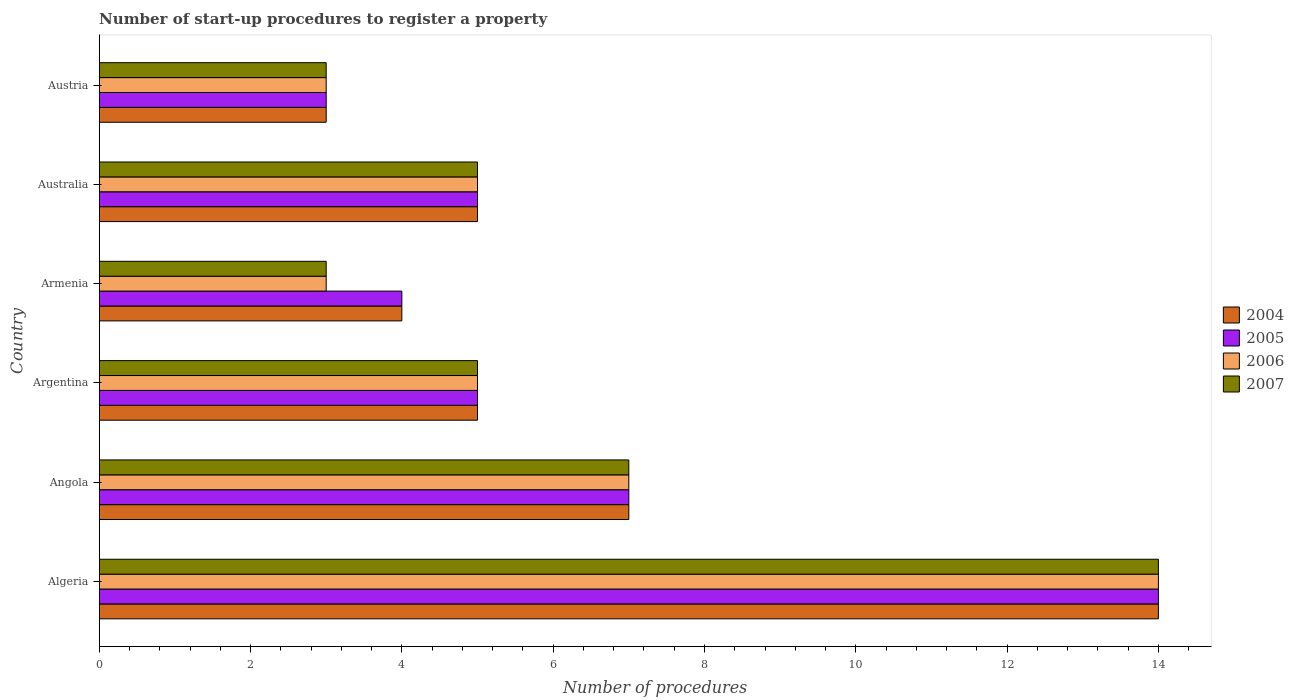How many groups of bars are there?
Offer a terse response. 6. Are the number of bars per tick equal to the number of legend labels?
Your response must be concise. Yes. Across all countries, what is the maximum number of procedures required to register a property in 2006?
Provide a short and direct response. 14. Across all countries, what is the minimum number of procedures required to register a property in 2006?
Ensure brevity in your answer.  3. In which country was the number of procedures required to register a property in 2006 maximum?
Give a very brief answer. Algeria. In which country was the number of procedures required to register a property in 2006 minimum?
Give a very brief answer. Armenia. What is the difference between the number of procedures required to register a property in 2005 in Algeria and that in Armenia?
Provide a short and direct response. 10. What is the average number of procedures required to register a property in 2005 per country?
Ensure brevity in your answer.  6.33. What is the difference between the number of procedures required to register a property in 2005 and number of procedures required to register a property in 2006 in Australia?
Give a very brief answer. 0. In how many countries, is the number of procedures required to register a property in 2005 greater than 8.8 ?
Provide a short and direct response. 1. What is the ratio of the number of procedures required to register a property in 2006 in Australia to that in Austria?
Make the answer very short. 1.67. Is the difference between the number of procedures required to register a property in 2005 in Armenia and Australia greater than the difference between the number of procedures required to register a property in 2006 in Armenia and Australia?
Your answer should be compact. Yes. What is the difference between the highest and the second highest number of procedures required to register a property in 2007?
Provide a short and direct response. 7. What is the difference between the highest and the lowest number of procedures required to register a property in 2004?
Offer a very short reply. 11. Is it the case that in every country, the sum of the number of procedures required to register a property in 2004 and number of procedures required to register a property in 2007 is greater than the number of procedures required to register a property in 2005?
Offer a terse response. Yes. How many bars are there?
Offer a terse response. 24. Are all the bars in the graph horizontal?
Give a very brief answer. Yes. How many countries are there in the graph?
Keep it short and to the point. 6. Are the values on the major ticks of X-axis written in scientific E-notation?
Your response must be concise. No. Does the graph contain grids?
Offer a terse response. No. Where does the legend appear in the graph?
Your answer should be compact. Center right. How many legend labels are there?
Your response must be concise. 4. How are the legend labels stacked?
Give a very brief answer. Vertical. What is the title of the graph?
Keep it short and to the point. Number of start-up procedures to register a property. What is the label or title of the X-axis?
Provide a short and direct response. Number of procedures. What is the label or title of the Y-axis?
Keep it short and to the point. Country. What is the Number of procedures of 2004 in Algeria?
Keep it short and to the point. 14. What is the Number of procedures of 2006 in Algeria?
Your response must be concise. 14. What is the Number of procedures of 2004 in Angola?
Keep it short and to the point. 7. What is the Number of procedures of 2007 in Angola?
Ensure brevity in your answer.  7. What is the Number of procedures in 2007 in Argentina?
Keep it short and to the point. 5. What is the Number of procedures of 2005 in Armenia?
Your answer should be very brief. 4. What is the Number of procedures of 2005 in Australia?
Your response must be concise. 5. What is the Number of procedures of 2006 in Australia?
Your answer should be very brief. 5. What is the Number of procedures in 2004 in Austria?
Give a very brief answer. 3. What is the Number of procedures in 2007 in Austria?
Provide a short and direct response. 3. Across all countries, what is the maximum Number of procedures of 2004?
Ensure brevity in your answer.  14. Across all countries, what is the maximum Number of procedures of 2006?
Your answer should be compact. 14. Across all countries, what is the maximum Number of procedures of 2007?
Your answer should be compact. 14. Across all countries, what is the minimum Number of procedures in 2004?
Offer a very short reply. 3. Across all countries, what is the minimum Number of procedures in 2005?
Provide a short and direct response. 3. Across all countries, what is the minimum Number of procedures in 2006?
Provide a short and direct response. 3. What is the total Number of procedures of 2004 in the graph?
Give a very brief answer. 38. What is the difference between the Number of procedures of 2006 in Algeria and that in Angola?
Give a very brief answer. 7. What is the difference between the Number of procedures in 2005 in Algeria and that in Argentina?
Provide a succinct answer. 9. What is the difference between the Number of procedures of 2006 in Algeria and that in Argentina?
Provide a short and direct response. 9. What is the difference between the Number of procedures in 2007 in Algeria and that in Argentina?
Keep it short and to the point. 9. What is the difference between the Number of procedures of 2004 in Algeria and that in Armenia?
Your answer should be very brief. 10. What is the difference between the Number of procedures in 2006 in Algeria and that in Armenia?
Give a very brief answer. 11. What is the difference between the Number of procedures in 2004 in Algeria and that in Australia?
Your response must be concise. 9. What is the difference between the Number of procedures of 2007 in Algeria and that in Australia?
Your answer should be very brief. 9. What is the difference between the Number of procedures in 2004 in Angola and that in Argentina?
Ensure brevity in your answer.  2. What is the difference between the Number of procedures in 2007 in Angola and that in Argentina?
Ensure brevity in your answer.  2. What is the difference between the Number of procedures of 2006 in Angola and that in Armenia?
Offer a very short reply. 4. What is the difference between the Number of procedures in 2007 in Angola and that in Armenia?
Provide a short and direct response. 4. What is the difference between the Number of procedures in 2006 in Angola and that in Australia?
Your response must be concise. 2. What is the difference between the Number of procedures in 2007 in Angola and that in Australia?
Offer a very short reply. 2. What is the difference between the Number of procedures of 2004 in Angola and that in Austria?
Your answer should be very brief. 4. What is the difference between the Number of procedures in 2005 in Angola and that in Austria?
Ensure brevity in your answer.  4. What is the difference between the Number of procedures in 2004 in Argentina and that in Armenia?
Offer a terse response. 1. What is the difference between the Number of procedures of 2005 in Argentina and that in Armenia?
Provide a short and direct response. 1. What is the difference between the Number of procedures of 2004 in Argentina and that in Australia?
Make the answer very short. 0. What is the difference between the Number of procedures of 2005 in Argentina and that in Australia?
Keep it short and to the point. 0. What is the difference between the Number of procedures in 2007 in Argentina and that in Australia?
Your answer should be compact. 0. What is the difference between the Number of procedures of 2006 in Argentina and that in Austria?
Your answer should be very brief. 2. What is the difference between the Number of procedures in 2007 in Argentina and that in Austria?
Your answer should be very brief. 2. What is the difference between the Number of procedures in 2005 in Armenia and that in Australia?
Offer a very short reply. -1. What is the difference between the Number of procedures of 2007 in Armenia and that in Australia?
Keep it short and to the point. -2. What is the difference between the Number of procedures in 2006 in Armenia and that in Austria?
Your answer should be compact. 0. What is the difference between the Number of procedures in 2007 in Armenia and that in Austria?
Give a very brief answer. 0. What is the difference between the Number of procedures of 2005 in Australia and that in Austria?
Your response must be concise. 2. What is the difference between the Number of procedures of 2006 in Australia and that in Austria?
Your response must be concise. 2. What is the difference between the Number of procedures of 2007 in Australia and that in Austria?
Keep it short and to the point. 2. What is the difference between the Number of procedures in 2004 in Algeria and the Number of procedures in 2005 in Angola?
Ensure brevity in your answer.  7. What is the difference between the Number of procedures in 2004 in Algeria and the Number of procedures in 2006 in Angola?
Offer a terse response. 7. What is the difference between the Number of procedures in 2005 in Algeria and the Number of procedures in 2006 in Angola?
Provide a short and direct response. 7. What is the difference between the Number of procedures in 2004 in Algeria and the Number of procedures in 2007 in Argentina?
Your response must be concise. 9. What is the difference between the Number of procedures of 2005 in Algeria and the Number of procedures of 2006 in Argentina?
Make the answer very short. 9. What is the difference between the Number of procedures in 2006 in Algeria and the Number of procedures in 2007 in Argentina?
Offer a terse response. 9. What is the difference between the Number of procedures of 2004 in Algeria and the Number of procedures of 2005 in Armenia?
Provide a short and direct response. 10. What is the difference between the Number of procedures in 2004 in Algeria and the Number of procedures in 2007 in Armenia?
Offer a very short reply. 11. What is the difference between the Number of procedures in 2005 in Algeria and the Number of procedures in 2007 in Armenia?
Keep it short and to the point. 11. What is the difference between the Number of procedures in 2004 in Algeria and the Number of procedures in 2005 in Australia?
Your answer should be compact. 9. What is the difference between the Number of procedures in 2004 in Algeria and the Number of procedures in 2007 in Australia?
Your response must be concise. 9. What is the difference between the Number of procedures in 2005 in Algeria and the Number of procedures in 2007 in Australia?
Offer a very short reply. 9. What is the difference between the Number of procedures of 2004 in Algeria and the Number of procedures of 2006 in Austria?
Your answer should be very brief. 11. What is the difference between the Number of procedures in 2005 in Algeria and the Number of procedures in 2006 in Austria?
Make the answer very short. 11. What is the difference between the Number of procedures of 2005 in Algeria and the Number of procedures of 2007 in Austria?
Offer a terse response. 11. What is the difference between the Number of procedures in 2004 in Angola and the Number of procedures in 2005 in Argentina?
Provide a short and direct response. 2. What is the difference between the Number of procedures of 2004 in Angola and the Number of procedures of 2006 in Argentina?
Provide a succinct answer. 2. What is the difference between the Number of procedures of 2004 in Angola and the Number of procedures of 2007 in Argentina?
Offer a terse response. 2. What is the difference between the Number of procedures of 2005 in Angola and the Number of procedures of 2006 in Argentina?
Keep it short and to the point. 2. What is the difference between the Number of procedures in 2006 in Angola and the Number of procedures in 2007 in Argentina?
Provide a succinct answer. 2. What is the difference between the Number of procedures in 2004 in Angola and the Number of procedures in 2007 in Armenia?
Make the answer very short. 4. What is the difference between the Number of procedures of 2005 in Angola and the Number of procedures of 2007 in Armenia?
Offer a terse response. 4. What is the difference between the Number of procedures of 2006 in Angola and the Number of procedures of 2007 in Armenia?
Your answer should be compact. 4. What is the difference between the Number of procedures of 2004 in Angola and the Number of procedures of 2006 in Australia?
Make the answer very short. 2. What is the difference between the Number of procedures of 2005 in Angola and the Number of procedures of 2007 in Australia?
Make the answer very short. 2. What is the difference between the Number of procedures of 2004 in Angola and the Number of procedures of 2005 in Austria?
Your answer should be very brief. 4. What is the difference between the Number of procedures in 2005 in Angola and the Number of procedures in 2007 in Austria?
Give a very brief answer. 4. What is the difference between the Number of procedures in 2006 in Angola and the Number of procedures in 2007 in Austria?
Offer a very short reply. 4. What is the difference between the Number of procedures of 2004 in Argentina and the Number of procedures of 2005 in Armenia?
Make the answer very short. 1. What is the difference between the Number of procedures in 2004 in Argentina and the Number of procedures in 2007 in Armenia?
Provide a short and direct response. 2. What is the difference between the Number of procedures of 2005 in Argentina and the Number of procedures of 2006 in Armenia?
Your answer should be very brief. 2. What is the difference between the Number of procedures of 2006 in Argentina and the Number of procedures of 2007 in Armenia?
Your answer should be compact. 2. What is the difference between the Number of procedures in 2004 in Argentina and the Number of procedures in 2005 in Australia?
Offer a terse response. 0. What is the difference between the Number of procedures in 2004 in Argentina and the Number of procedures in 2006 in Australia?
Your response must be concise. 0. What is the difference between the Number of procedures of 2004 in Argentina and the Number of procedures of 2007 in Australia?
Give a very brief answer. 0. What is the difference between the Number of procedures in 2005 in Argentina and the Number of procedures in 2007 in Australia?
Your answer should be very brief. 0. What is the difference between the Number of procedures in 2004 in Argentina and the Number of procedures in 2007 in Austria?
Your answer should be very brief. 2. What is the difference between the Number of procedures of 2005 in Argentina and the Number of procedures of 2006 in Austria?
Ensure brevity in your answer.  2. What is the difference between the Number of procedures of 2005 in Argentina and the Number of procedures of 2007 in Austria?
Provide a succinct answer. 2. What is the difference between the Number of procedures of 2004 in Armenia and the Number of procedures of 2005 in Australia?
Your response must be concise. -1. What is the difference between the Number of procedures in 2004 in Armenia and the Number of procedures in 2006 in Australia?
Your answer should be very brief. -1. What is the difference between the Number of procedures of 2005 in Armenia and the Number of procedures of 2006 in Australia?
Ensure brevity in your answer.  -1. What is the difference between the Number of procedures of 2005 in Armenia and the Number of procedures of 2007 in Australia?
Your answer should be compact. -1. What is the difference between the Number of procedures of 2004 in Armenia and the Number of procedures of 2005 in Austria?
Your response must be concise. 1. What is the difference between the Number of procedures in 2005 in Armenia and the Number of procedures in 2006 in Austria?
Keep it short and to the point. 1. What is the difference between the Number of procedures of 2005 in Armenia and the Number of procedures of 2007 in Austria?
Give a very brief answer. 1. What is the difference between the Number of procedures in 2006 in Armenia and the Number of procedures in 2007 in Austria?
Ensure brevity in your answer.  0. What is the difference between the Number of procedures in 2004 in Australia and the Number of procedures in 2005 in Austria?
Provide a succinct answer. 2. What is the difference between the Number of procedures of 2005 in Australia and the Number of procedures of 2006 in Austria?
Provide a succinct answer. 2. What is the average Number of procedures of 2004 per country?
Provide a short and direct response. 6.33. What is the average Number of procedures in 2005 per country?
Offer a very short reply. 6.33. What is the average Number of procedures of 2006 per country?
Make the answer very short. 6.17. What is the average Number of procedures in 2007 per country?
Your answer should be compact. 6.17. What is the difference between the Number of procedures in 2004 and Number of procedures in 2006 in Algeria?
Ensure brevity in your answer.  0. What is the difference between the Number of procedures in 2006 and Number of procedures in 2007 in Algeria?
Offer a terse response. 0. What is the difference between the Number of procedures in 2004 and Number of procedures in 2007 in Angola?
Your response must be concise. 0. What is the difference between the Number of procedures in 2005 and Number of procedures in 2007 in Angola?
Provide a succinct answer. 0. What is the difference between the Number of procedures of 2006 and Number of procedures of 2007 in Angola?
Make the answer very short. 0. What is the difference between the Number of procedures in 2004 and Number of procedures in 2006 in Argentina?
Provide a succinct answer. 0. What is the difference between the Number of procedures of 2004 and Number of procedures of 2007 in Argentina?
Your answer should be compact. 0. What is the difference between the Number of procedures in 2005 and Number of procedures in 2006 in Argentina?
Provide a succinct answer. 0. What is the difference between the Number of procedures of 2006 and Number of procedures of 2007 in Argentina?
Make the answer very short. 0. What is the difference between the Number of procedures in 2004 and Number of procedures in 2005 in Armenia?
Your answer should be very brief. 0. What is the difference between the Number of procedures of 2006 and Number of procedures of 2007 in Armenia?
Ensure brevity in your answer.  0. What is the difference between the Number of procedures of 2004 and Number of procedures of 2005 in Australia?
Offer a terse response. 0. What is the difference between the Number of procedures of 2004 and Number of procedures of 2006 in Australia?
Offer a very short reply. 0. What is the difference between the Number of procedures of 2005 and Number of procedures of 2006 in Australia?
Make the answer very short. 0. What is the difference between the Number of procedures of 2006 and Number of procedures of 2007 in Australia?
Keep it short and to the point. 0. What is the difference between the Number of procedures of 2004 and Number of procedures of 2005 in Austria?
Keep it short and to the point. 0. What is the difference between the Number of procedures in 2005 and Number of procedures in 2006 in Austria?
Offer a terse response. 0. What is the difference between the Number of procedures of 2006 and Number of procedures of 2007 in Austria?
Offer a very short reply. 0. What is the ratio of the Number of procedures of 2005 in Algeria to that in Angola?
Ensure brevity in your answer.  2. What is the ratio of the Number of procedures of 2006 in Algeria to that in Angola?
Your answer should be very brief. 2. What is the ratio of the Number of procedures in 2004 in Algeria to that in Argentina?
Give a very brief answer. 2.8. What is the ratio of the Number of procedures in 2005 in Algeria to that in Argentina?
Give a very brief answer. 2.8. What is the ratio of the Number of procedures of 2007 in Algeria to that in Argentina?
Keep it short and to the point. 2.8. What is the ratio of the Number of procedures of 2004 in Algeria to that in Armenia?
Ensure brevity in your answer.  3.5. What is the ratio of the Number of procedures in 2006 in Algeria to that in Armenia?
Give a very brief answer. 4.67. What is the ratio of the Number of procedures in 2007 in Algeria to that in Armenia?
Ensure brevity in your answer.  4.67. What is the ratio of the Number of procedures in 2004 in Algeria to that in Australia?
Your response must be concise. 2.8. What is the ratio of the Number of procedures in 2007 in Algeria to that in Australia?
Offer a terse response. 2.8. What is the ratio of the Number of procedures of 2004 in Algeria to that in Austria?
Your response must be concise. 4.67. What is the ratio of the Number of procedures of 2005 in Algeria to that in Austria?
Your answer should be compact. 4.67. What is the ratio of the Number of procedures in 2006 in Algeria to that in Austria?
Keep it short and to the point. 4.67. What is the ratio of the Number of procedures in 2007 in Algeria to that in Austria?
Make the answer very short. 4.67. What is the ratio of the Number of procedures in 2004 in Angola to that in Argentina?
Keep it short and to the point. 1.4. What is the ratio of the Number of procedures in 2007 in Angola to that in Argentina?
Ensure brevity in your answer.  1.4. What is the ratio of the Number of procedures in 2006 in Angola to that in Armenia?
Provide a succinct answer. 2.33. What is the ratio of the Number of procedures in 2007 in Angola to that in Armenia?
Your response must be concise. 2.33. What is the ratio of the Number of procedures in 2006 in Angola to that in Australia?
Offer a terse response. 1.4. What is the ratio of the Number of procedures in 2007 in Angola to that in Australia?
Give a very brief answer. 1.4. What is the ratio of the Number of procedures in 2004 in Angola to that in Austria?
Ensure brevity in your answer.  2.33. What is the ratio of the Number of procedures in 2005 in Angola to that in Austria?
Your answer should be very brief. 2.33. What is the ratio of the Number of procedures of 2006 in Angola to that in Austria?
Make the answer very short. 2.33. What is the ratio of the Number of procedures of 2007 in Angola to that in Austria?
Offer a very short reply. 2.33. What is the ratio of the Number of procedures in 2004 in Argentina to that in Armenia?
Offer a terse response. 1.25. What is the ratio of the Number of procedures of 2006 in Argentina to that in Armenia?
Offer a very short reply. 1.67. What is the ratio of the Number of procedures in 2007 in Argentina to that in Armenia?
Your answer should be compact. 1.67. What is the ratio of the Number of procedures in 2004 in Argentina to that in Austria?
Provide a short and direct response. 1.67. What is the ratio of the Number of procedures in 2007 in Argentina to that in Austria?
Keep it short and to the point. 1.67. What is the ratio of the Number of procedures of 2005 in Armenia to that in Australia?
Give a very brief answer. 0.8. What is the ratio of the Number of procedures of 2007 in Armenia to that in Australia?
Your response must be concise. 0.6. What is the ratio of the Number of procedures in 2004 in Armenia to that in Austria?
Make the answer very short. 1.33. What is the ratio of the Number of procedures in 2005 in Armenia to that in Austria?
Offer a terse response. 1.33. What is the ratio of the Number of procedures of 2006 in Armenia to that in Austria?
Offer a terse response. 1. What is the ratio of the Number of procedures of 2004 in Australia to that in Austria?
Provide a short and direct response. 1.67. What is the ratio of the Number of procedures of 2005 in Australia to that in Austria?
Provide a short and direct response. 1.67. What is the ratio of the Number of procedures in 2006 in Australia to that in Austria?
Give a very brief answer. 1.67. What is the ratio of the Number of procedures in 2007 in Australia to that in Austria?
Give a very brief answer. 1.67. What is the difference between the highest and the second highest Number of procedures of 2004?
Make the answer very short. 7. What is the difference between the highest and the second highest Number of procedures of 2005?
Give a very brief answer. 7. What is the difference between the highest and the second highest Number of procedures of 2007?
Make the answer very short. 7. 